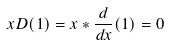<formula> <loc_0><loc_0><loc_500><loc_500>x D ( 1 ) = x * \frac { d } { d x } ( 1 ) = 0</formula> 